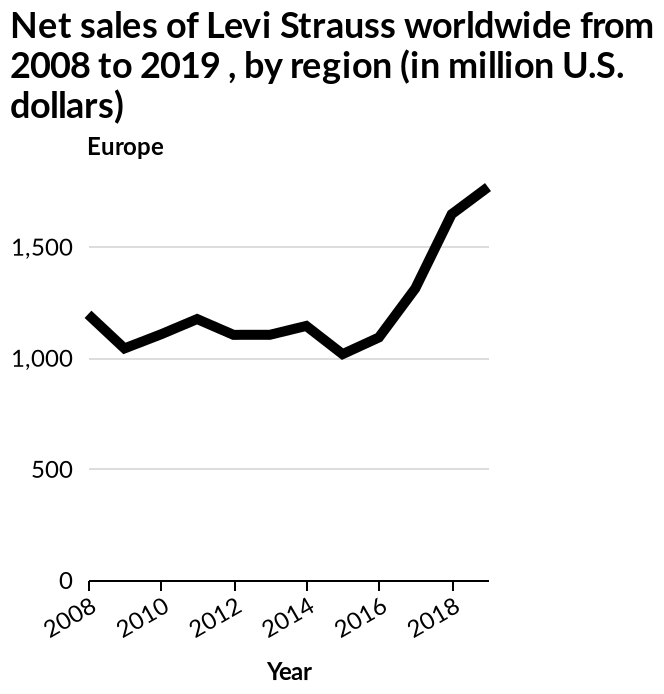<image>
Has Levi Strauss seen a significant improvement in sales after 2015? Yes, Levi Strauss has seen a significant improvement in sales after 2015. How have Levi Strauss sales been from 2016 onwards?  Levi Strauss sales have spiked dramatically from 2016 onwards. 